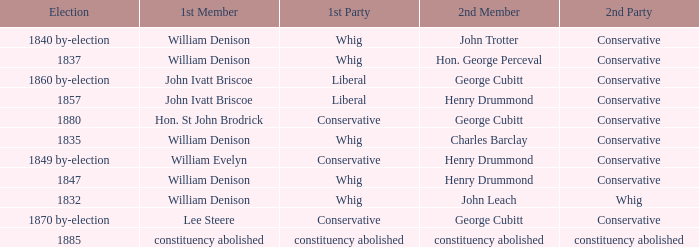Which party's 1st member is John Ivatt Briscoe in an election in 1857? Liberal. 